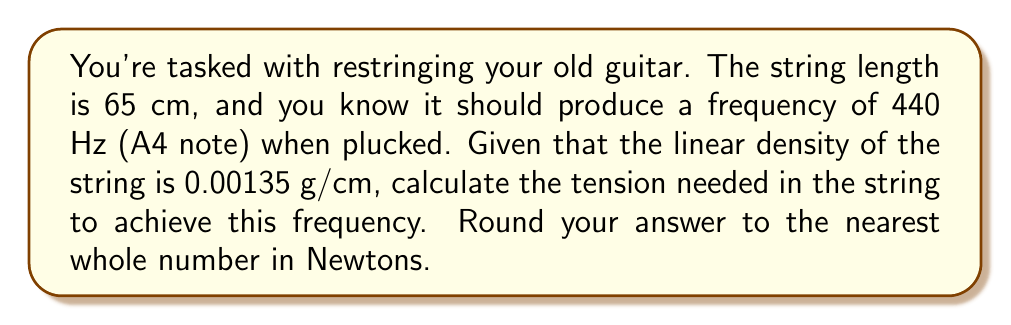What is the answer to this math problem? Let's approach this step-by-step using the wave equation for a vibrating string:

1) The frequency of a vibrating string is given by the equation:

   $$ f = \frac{1}{2L} \sqrt{\frac{T}{\mu}} $$

   Where:
   $f$ = frequency (Hz)
   $L$ = length of the string (m)
   $T$ = tension in the string (N)
   $\mu$ = linear density (kg/m)

2) We're given:
   $f = 440$ Hz
   $L = 65$ cm $= 0.65$ m
   $\mu = 0.00135$ g/cm $= 0.000135$ kg/m

3) Let's rearrange the equation to solve for $T$:

   $$ T = 4L^2f^2\mu $$

4) Now, let's substitute our values:

   $$ T = 4 * (0.65\text{ m})^2 * (440\text{ Hz})^2 * (0.000135\text{ kg/m}) $$

5) Calculate:

   $$ T = 4 * 0.4225 * 193600 * 0.000135 $$
   $$ T = 44.1936\text{ N} $$

6) Rounding to the nearest whole number:

   $$ T \approx 44\text{ N} $$
Answer: 44 N 